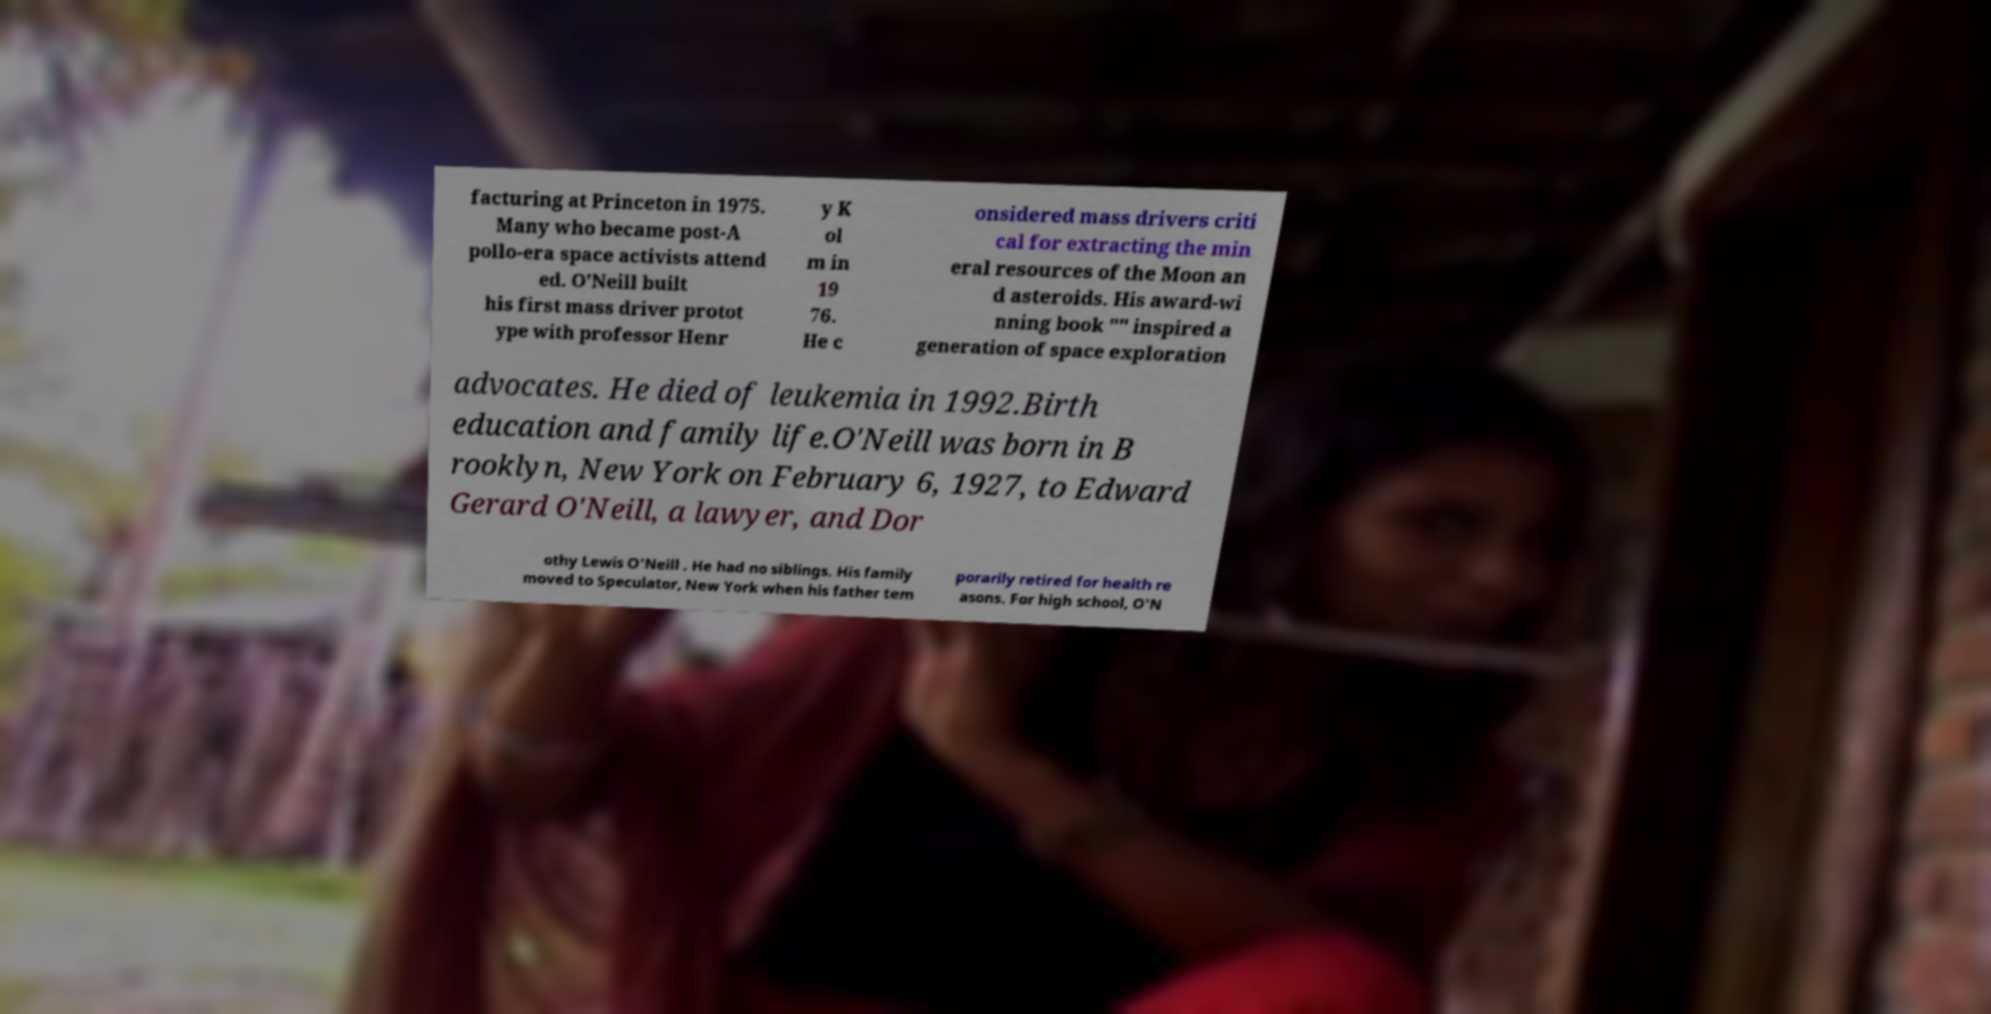I need the written content from this picture converted into text. Can you do that? facturing at Princeton in 1975. Many who became post-A pollo-era space activists attend ed. O'Neill built his first mass driver protot ype with professor Henr y K ol m in 19 76. He c onsidered mass drivers criti cal for extracting the min eral resources of the Moon an d asteroids. His award-wi nning book "" inspired a generation of space exploration advocates. He died of leukemia in 1992.Birth education and family life.O'Neill was born in B rooklyn, New York on February 6, 1927, to Edward Gerard O'Neill, a lawyer, and Dor othy Lewis O'Neill . He had no siblings. His family moved to Speculator, New York when his father tem porarily retired for health re asons. For high school, O'N 